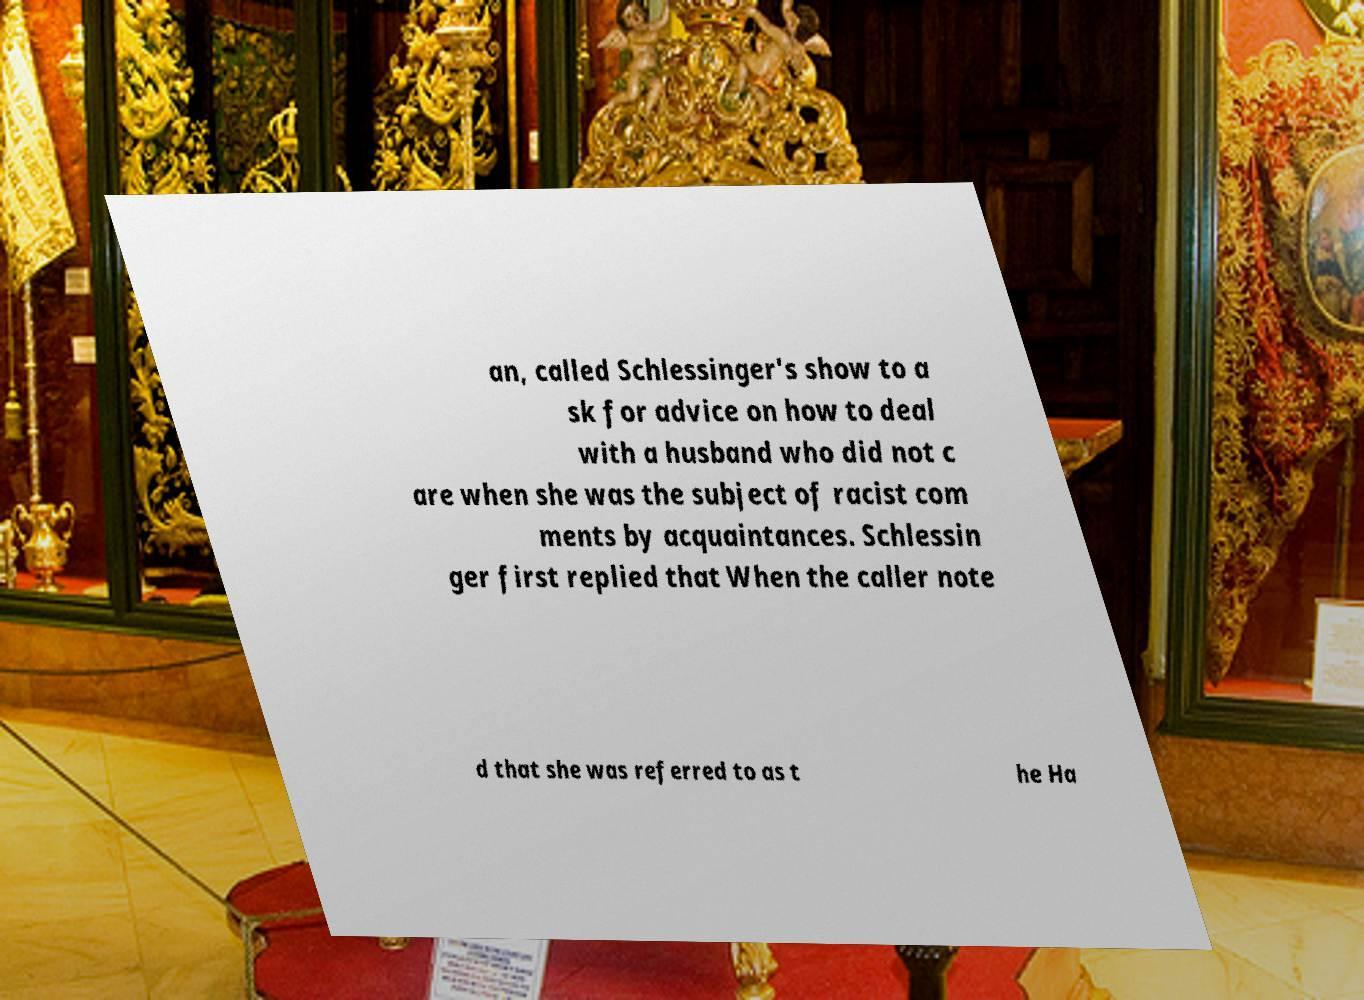For documentation purposes, I need the text within this image transcribed. Could you provide that? an, called Schlessinger's show to a sk for advice on how to deal with a husband who did not c are when she was the subject of racist com ments by acquaintances. Schlessin ger first replied that When the caller note d that she was referred to as t he Ha 